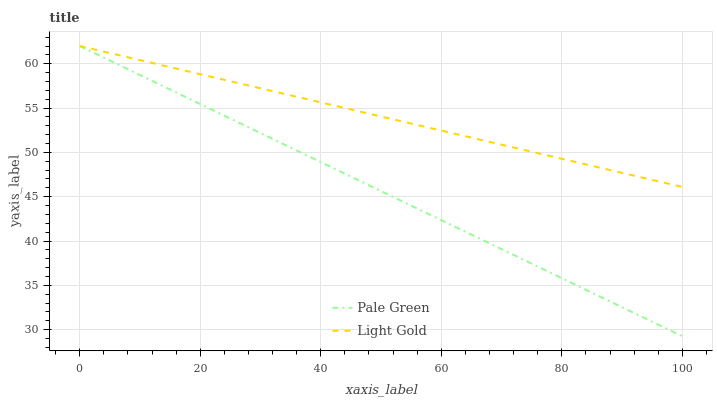Does Pale Green have the minimum area under the curve?
Answer yes or no. Yes. Does Light Gold have the maximum area under the curve?
Answer yes or no. Yes. Does Light Gold have the minimum area under the curve?
Answer yes or no. No. Is Pale Green the smoothest?
Answer yes or no. Yes. Is Light Gold the roughest?
Answer yes or no. Yes. Is Light Gold the smoothest?
Answer yes or no. No. Does Pale Green have the lowest value?
Answer yes or no. Yes. Does Light Gold have the lowest value?
Answer yes or no. No. Does Light Gold have the highest value?
Answer yes or no. Yes. Does Pale Green intersect Light Gold?
Answer yes or no. Yes. Is Pale Green less than Light Gold?
Answer yes or no. No. Is Pale Green greater than Light Gold?
Answer yes or no. No. 